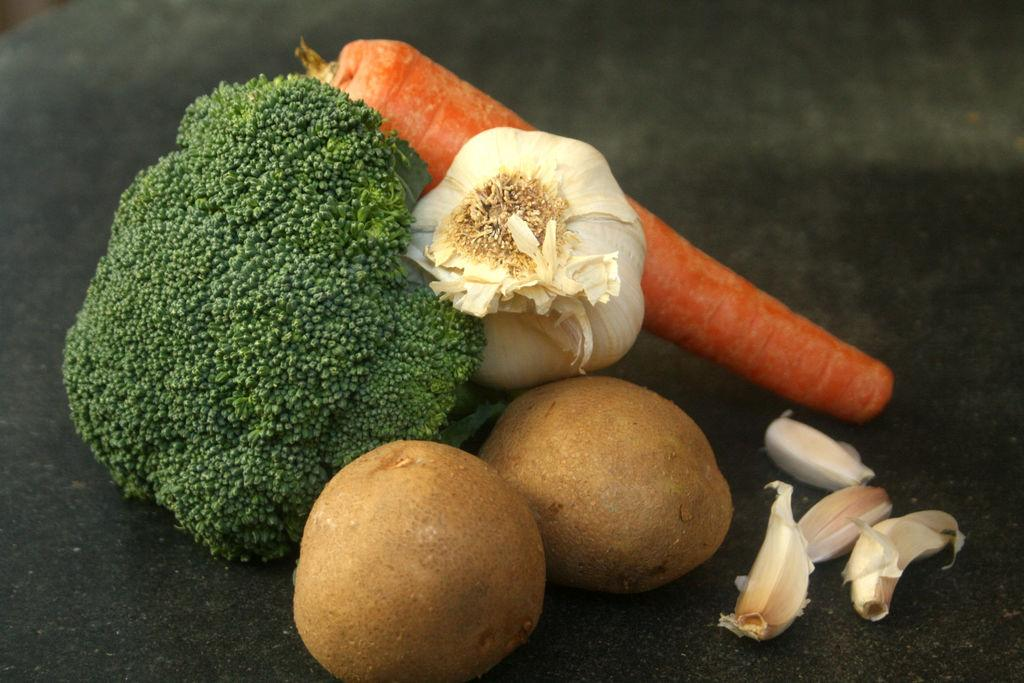What types of food can be seen in the image? There are fruits and vegetables in the image. Can you describe the variety of fruits and vegetables present? Unfortunately, the provided facts do not specify the variety of fruits and vegetables in the image. What song is the boy singing in the image? There is no boy or song present in the image; it only features fruits and vegetables. 